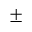Convert formula to latex. <formula><loc_0><loc_0><loc_500><loc_500>\pm</formula> 